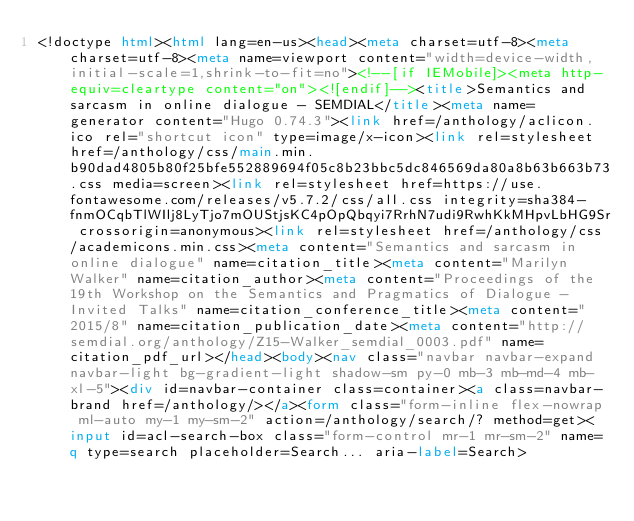<code> <loc_0><loc_0><loc_500><loc_500><_HTML_><!doctype html><html lang=en-us><head><meta charset=utf-8><meta charset=utf-8><meta name=viewport content="width=device-width,initial-scale=1,shrink-to-fit=no"><!--[if IEMobile]><meta http-equiv=cleartype content="on"><![endif]--><title>Semantics and sarcasm in online dialogue - SEMDIAL</title><meta name=generator content="Hugo 0.74.3"><link href=/anthology/aclicon.ico rel="shortcut icon" type=image/x-icon><link rel=stylesheet href=/anthology/css/main.min.b90dad4805b80f25bfe552889694f05c8b23bbc5dc846569da80a8b63b663b73.css media=screen><link rel=stylesheet href=https://use.fontawesome.com/releases/v5.7.2/css/all.css integrity=sha384-fnmOCqbTlWIlj8LyTjo7mOUStjsKC4pOpQbqyi7RrhN7udi9RwhKkMHpvLbHG9Sr crossorigin=anonymous><link rel=stylesheet href=/anthology/css/academicons.min.css><meta content="Semantics and sarcasm in online dialogue" name=citation_title><meta content="Marilyn Walker" name=citation_author><meta content="Proceedings of the 19th Workshop on the Semantics and Pragmatics of Dialogue - Invited Talks" name=citation_conference_title><meta content="2015/8" name=citation_publication_date><meta content="http://semdial.org/anthology/Z15-Walker_semdial_0003.pdf" name=citation_pdf_url></head><body><nav class="navbar navbar-expand navbar-light bg-gradient-light shadow-sm py-0 mb-3 mb-md-4 mb-xl-5"><div id=navbar-container class=container><a class=navbar-brand href=/anthology/></a><form class="form-inline flex-nowrap ml-auto my-1 my-sm-2" action=/anthology/search/? method=get><input id=acl-search-box class="form-control mr-1 mr-sm-2" name=q type=search placeholder=Search... aria-label=Search></code> 